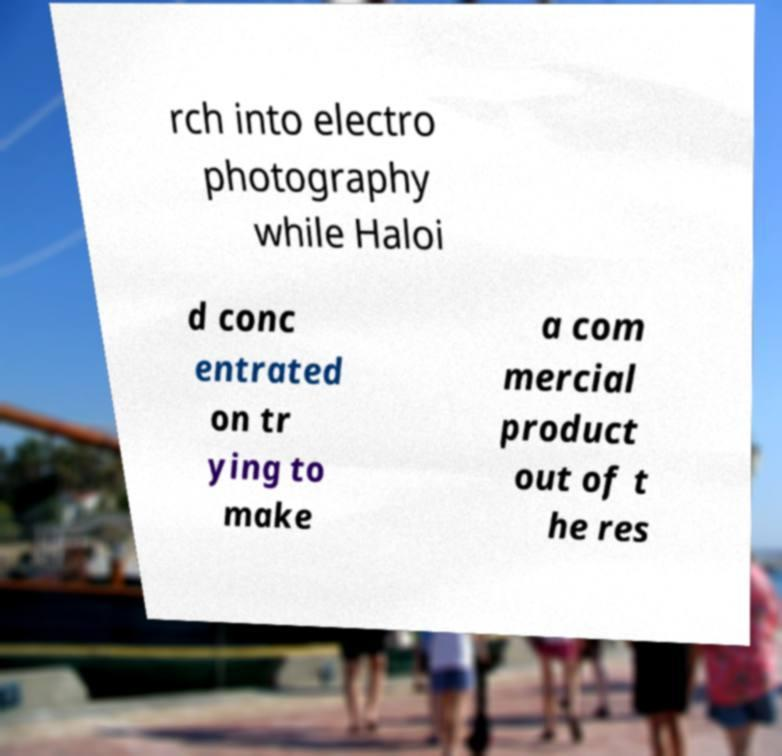What messages or text are displayed in this image? I need them in a readable, typed format. rch into electro photography while Haloi d conc entrated on tr ying to make a com mercial product out of t he res 